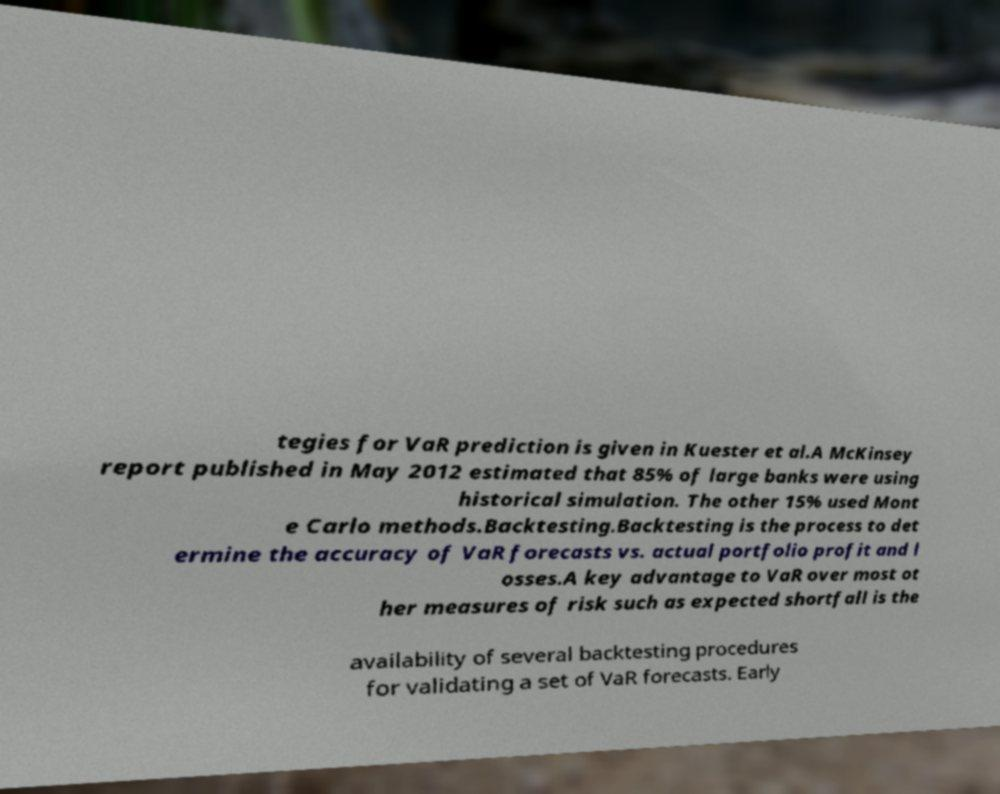Please identify and transcribe the text found in this image. tegies for VaR prediction is given in Kuester et al.A McKinsey report published in May 2012 estimated that 85% of large banks were using historical simulation. The other 15% used Mont e Carlo methods.Backtesting.Backtesting is the process to det ermine the accuracy of VaR forecasts vs. actual portfolio profit and l osses.A key advantage to VaR over most ot her measures of risk such as expected shortfall is the availability of several backtesting procedures for validating a set of VaR forecasts. Early 